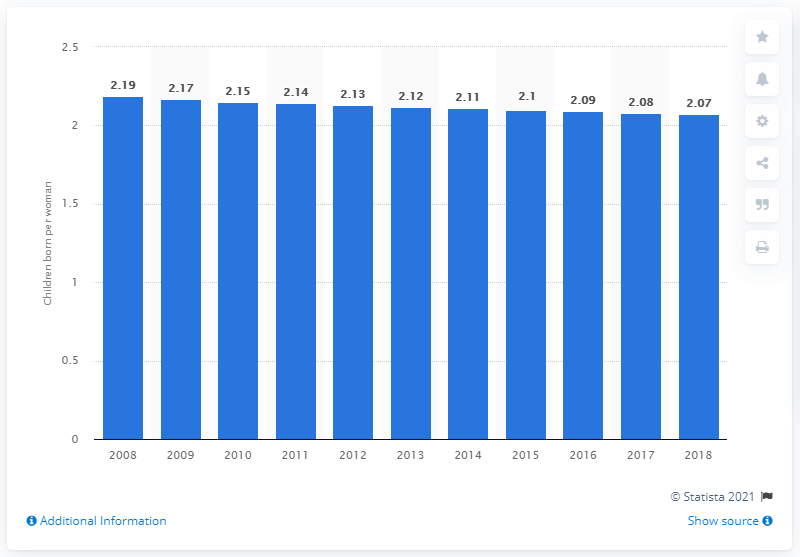Draw attention to some important aspects in this diagram. In 2018, Turkey's fertility rate was 2.07, which is slightly higher than the world average of 2.4. 